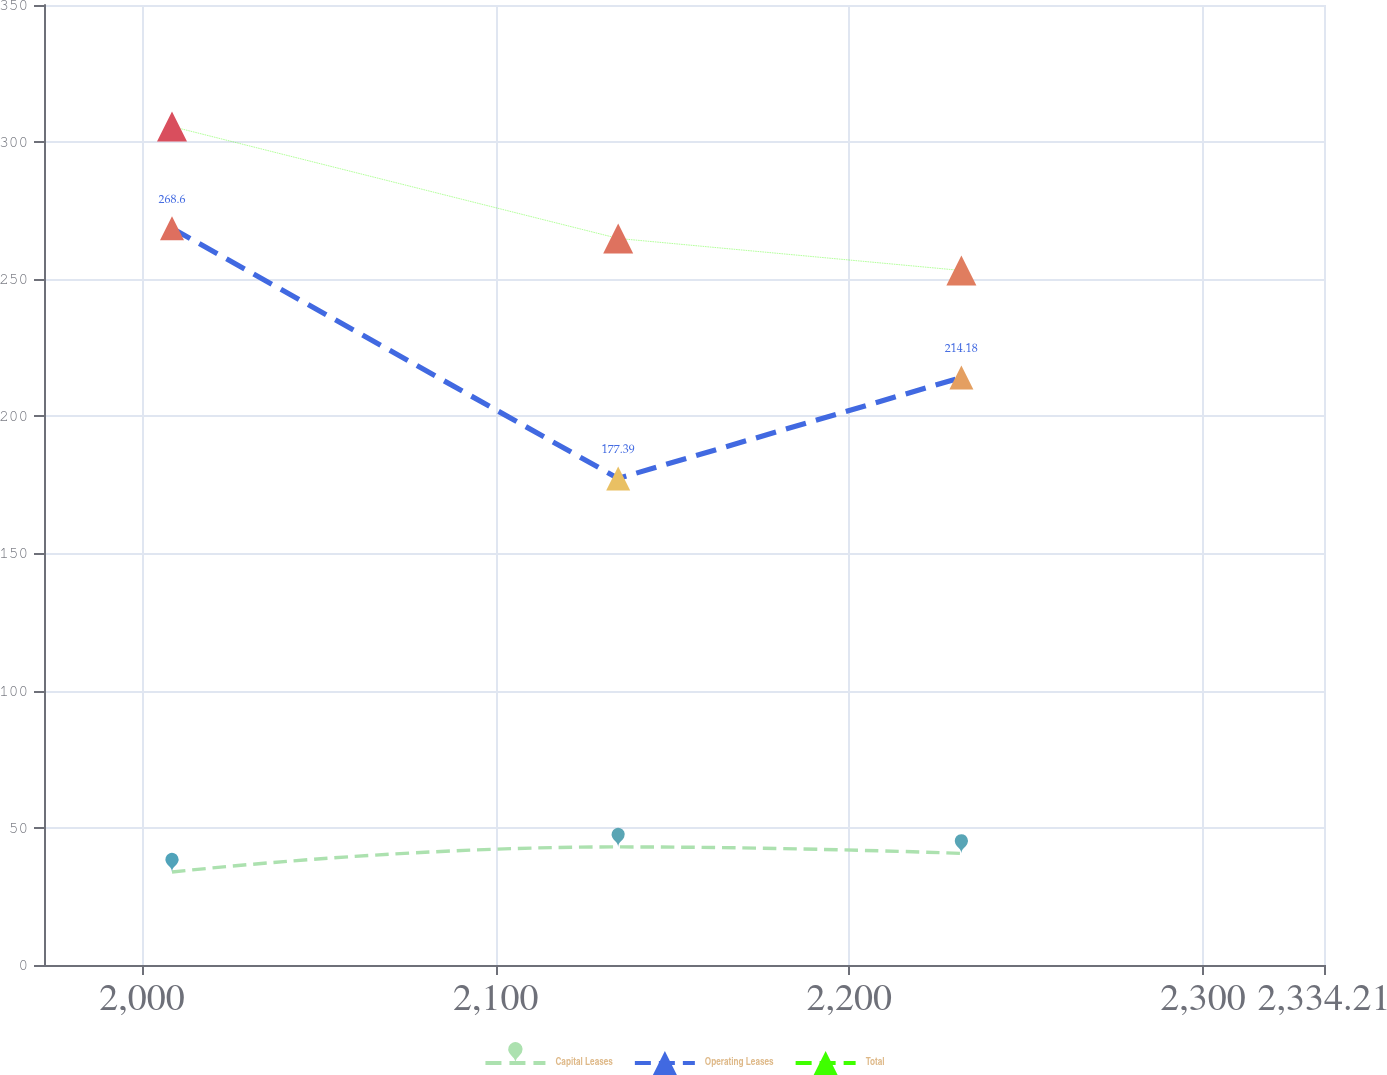Convert chart. <chart><loc_0><loc_0><loc_500><loc_500><line_chart><ecel><fcel>Capital Leases<fcel>Operating Leases<fcel>Total<nl><fcel>2008.5<fcel>33.89<fcel>268.6<fcel>305.7<nl><fcel>2134.65<fcel>43.05<fcel>177.39<fcel>264.89<nl><fcel>2231.68<fcel>40.69<fcel>214.18<fcel>253.21<nl><fcel>2334.78<fcel>42.22<fcel>161.85<fcel>188.9<nl><fcel>2370.4<fcel>34.72<fcel>188.06<fcel>241.53<nl></chart> 